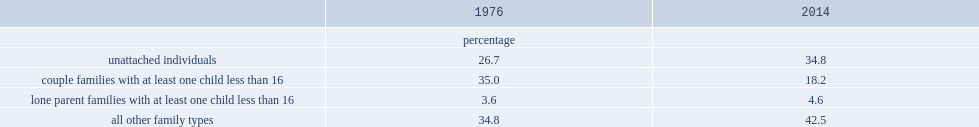In 2014,what were the percentages of couples and lone parents in canada respectively? 18.2 4.6. What was the percentage of family units with children aged less than 16 in 1976? 38.6. 